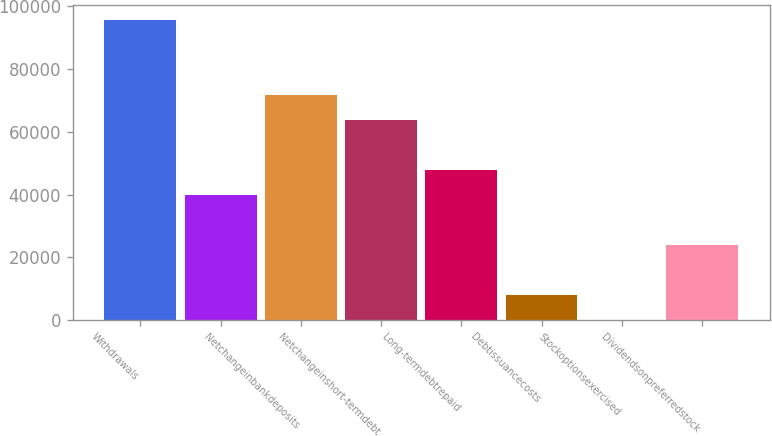Convert chart to OTSL. <chart><loc_0><loc_0><loc_500><loc_500><bar_chart><fcel>Withdrawals<fcel>Unnamed: 1<fcel>Netchangeinbankdeposits<fcel>Netchangeinshort-termdebt<fcel>Long-termdebtrepaid<fcel>Debtissuancecosts<fcel>Stockoptionsexercised<fcel>Dividendsonpreferredstock<nl><fcel>95757.2<fcel>39903.5<fcel>71819.9<fcel>63840.8<fcel>47882.6<fcel>7987.1<fcel>8<fcel>23945.3<nl></chart> 